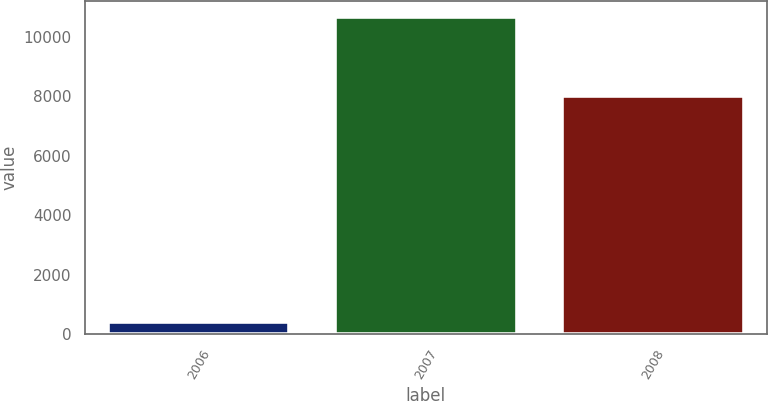Convert chart. <chart><loc_0><loc_0><loc_500><loc_500><bar_chart><fcel>2006<fcel>2007<fcel>2008<nl><fcel>408<fcel>10686<fcel>8018<nl></chart> 